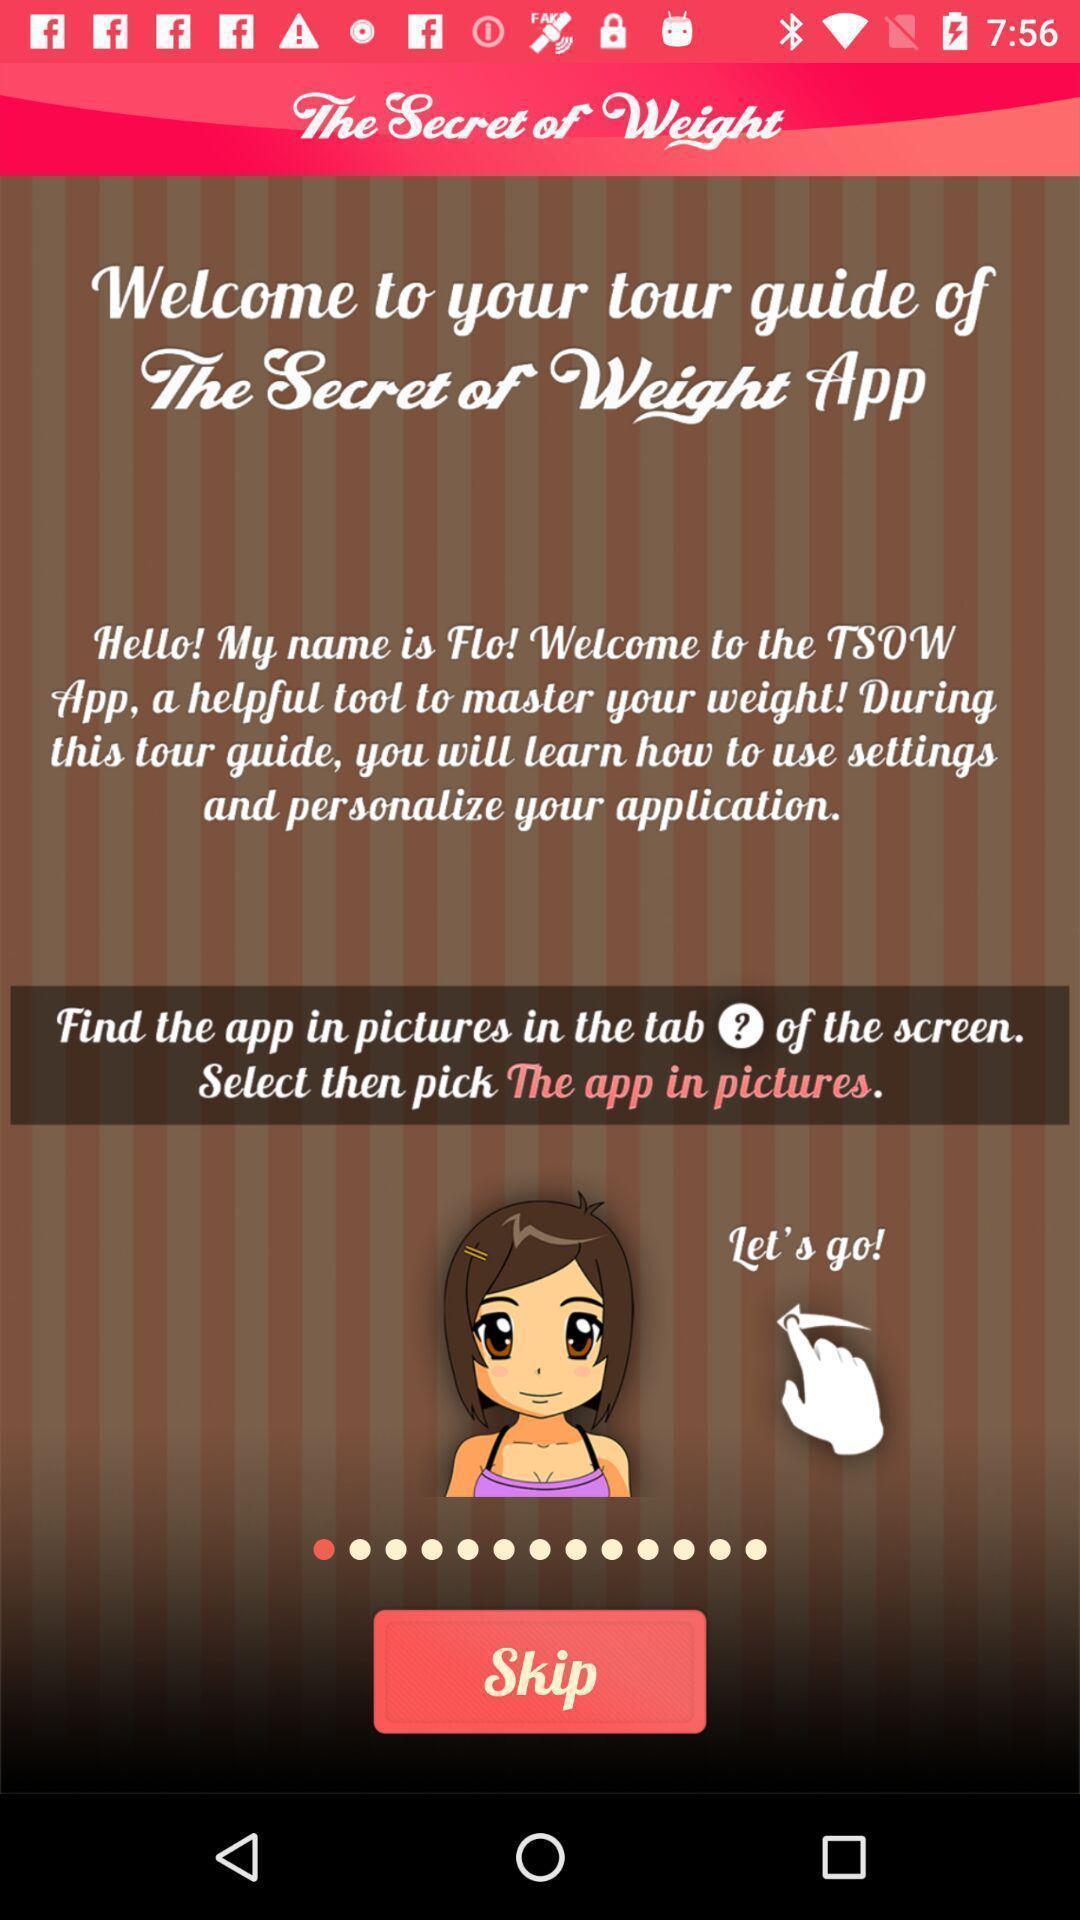Describe the content in this image. Welcome page showing tour guide. 